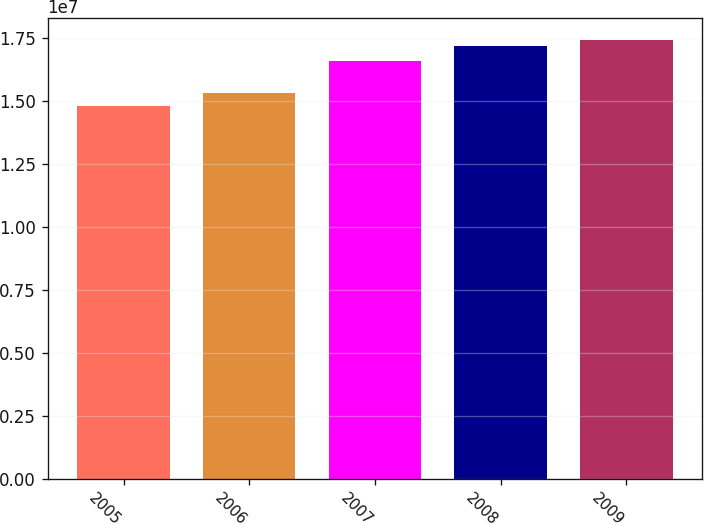Convert chart. <chart><loc_0><loc_0><loc_500><loc_500><bar_chart><fcel>2005<fcel>2006<fcel>2007<fcel>2008<fcel>2009<nl><fcel>1.4818e+07<fcel>1.5309e+07<fcel>1.6586e+07<fcel>1.7184e+07<fcel>1.74362e+07<nl></chart> 